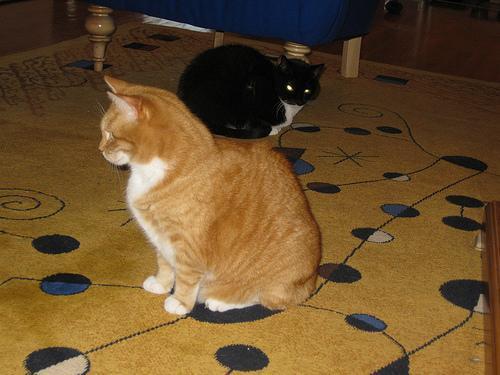How many cats?
Give a very brief answer. 2. 